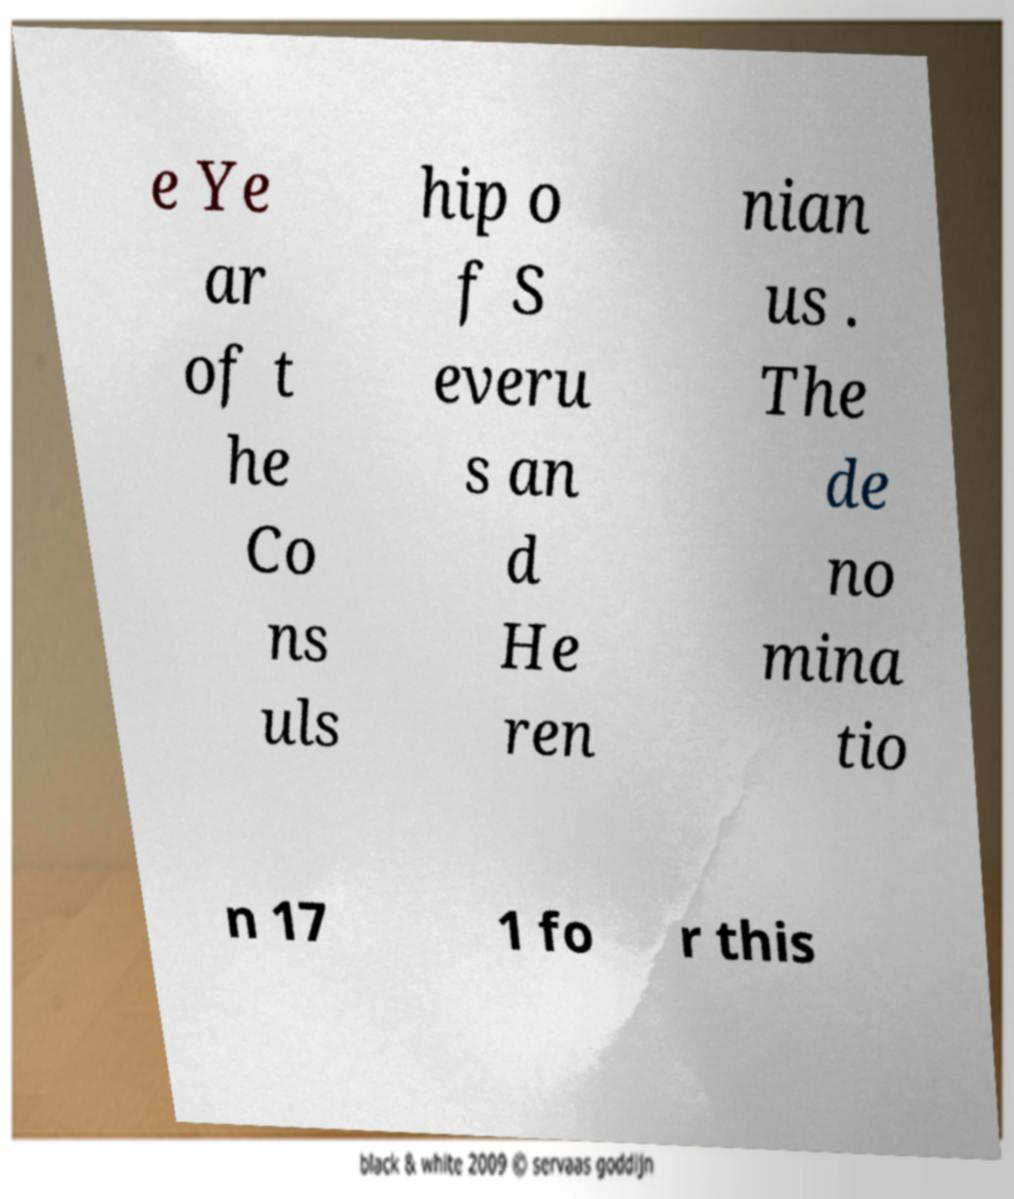Can you read and provide the text displayed in the image?This photo seems to have some interesting text. Can you extract and type it out for me? e Ye ar of t he Co ns uls hip o f S everu s an d He ren nian us . The de no mina tio n 17 1 fo r this 